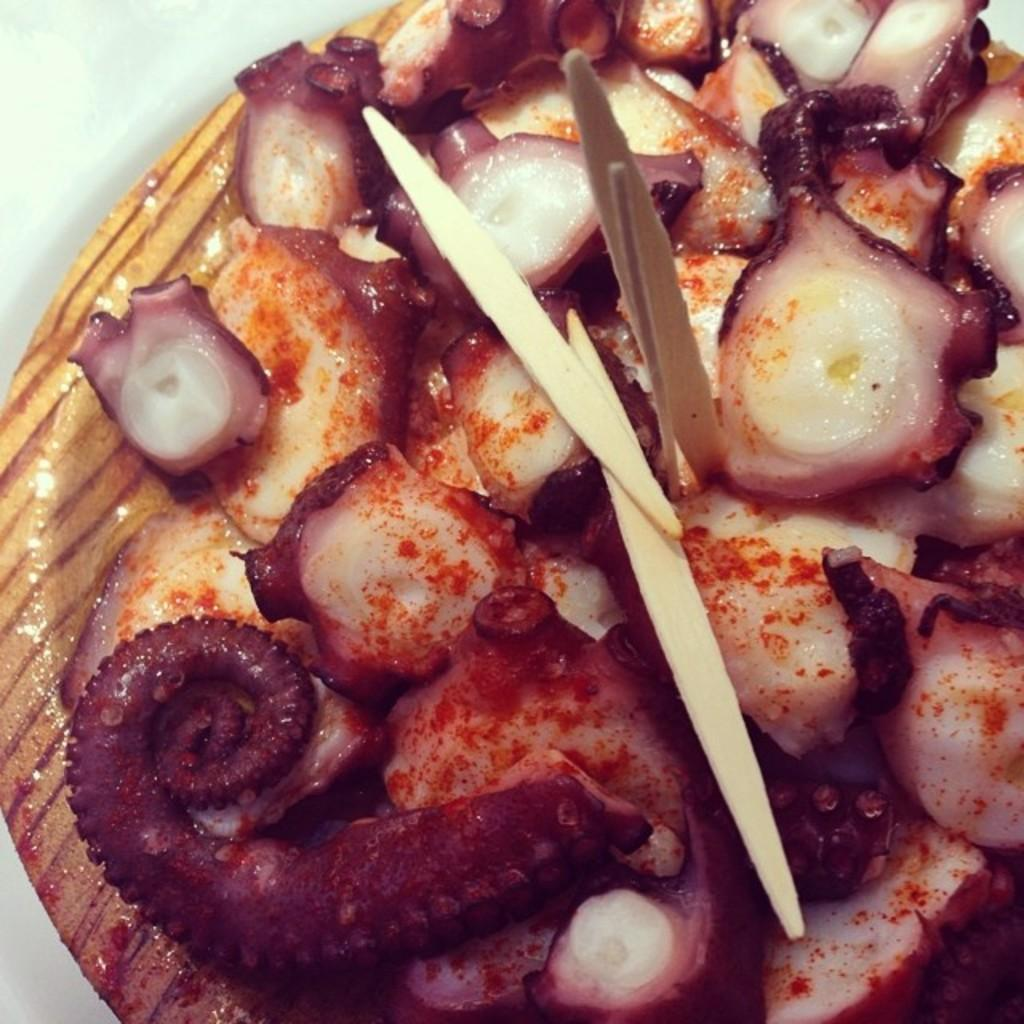What type of objects can be seen on the plate in the image? There are food items and small sticks present on the plate in the image. What is the plate resting on? The plate is on a platform. Can you describe the food items in the image? Unfortunately, the facts provided do not give specific details about the food items. What type of polish is being applied to the friends' nails in the image? There are no friends or nails present in the image; it only features food items, small sticks, a plate, and a platform. 